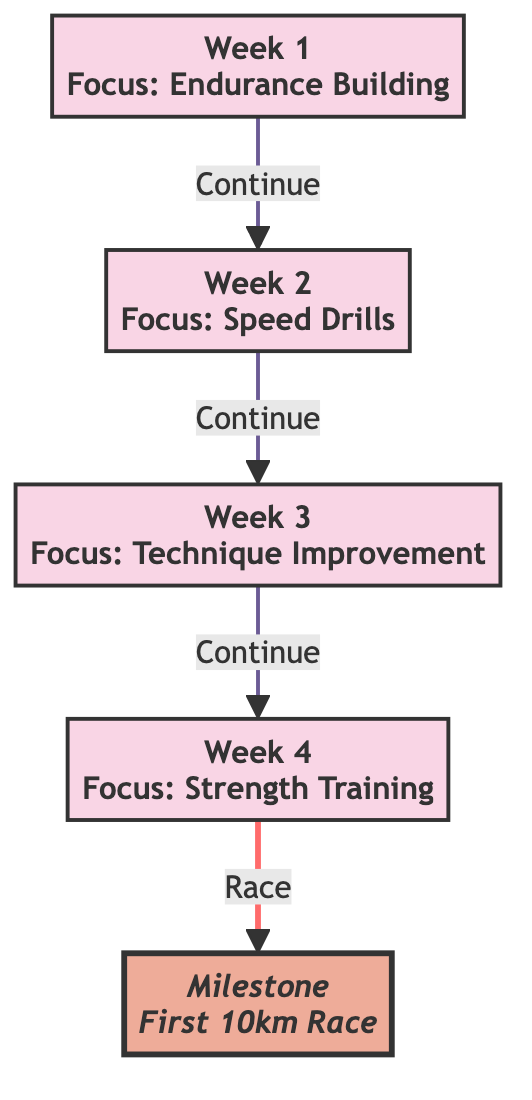What is the focus of Week 1? The diagram indicates that Week 1 has a focus on "Endurance Building". This information is explicitly stated within the node for Week 1.
Answer: Endurance Building How many weeks are there in the training schedule? By counting the individual week nodes in the diagram, we see there are four weeks indicated: Week 1, Week 2, Week 3, and Week 4.
Answer: 4 What is the milestone at the end of Week 4? The diagram presents a milestone linked to the end of Week 4, which is the "First 10km Race". This is indicated as a separate node connected to Week 4.
Answer: First 10km Race Which week focuses on Speed Drills? According to the diagram, Week 2 is solely dedicated to "Speed Drills", as highlighted in the corresponding node for that week.
Answer: Week 2 What is the relationship between Week 3 and Week 4? The diagram shows a direct connection indicating that after Week 3, the progression continues to Week 4. This implies a sequential training focus from technique improvement to strength training.
Answer: Continue What milestone is indicated after Week 4? The diagram illustrates that following Week 4, there is a milestone outlined, specifically the "First 10km Race". This indicates the end goal for that training cycle.
Answer: First 10km Race Which week comes after the week focused on technique improvement? The diagram indicates that after Week 3, which focuses on technique improvement, the flow progresses to Week 4. This shows the sequential nature of the training schedule.
Answer: Week 4 What color is used for the milestone node? The milestone node is colored with a distinctive fill (#eeac99) as described in the diagram's styling elements, differentiating it from the week nodes.
Answer: #eeac99 How does one transition from Week 4 to the milestone? The flowchart shows a connection from Week 4 directly to the milestone in the diagram, indicating that the activities of Week 4 culminate in the milestone of the first race.
Answer: Race 